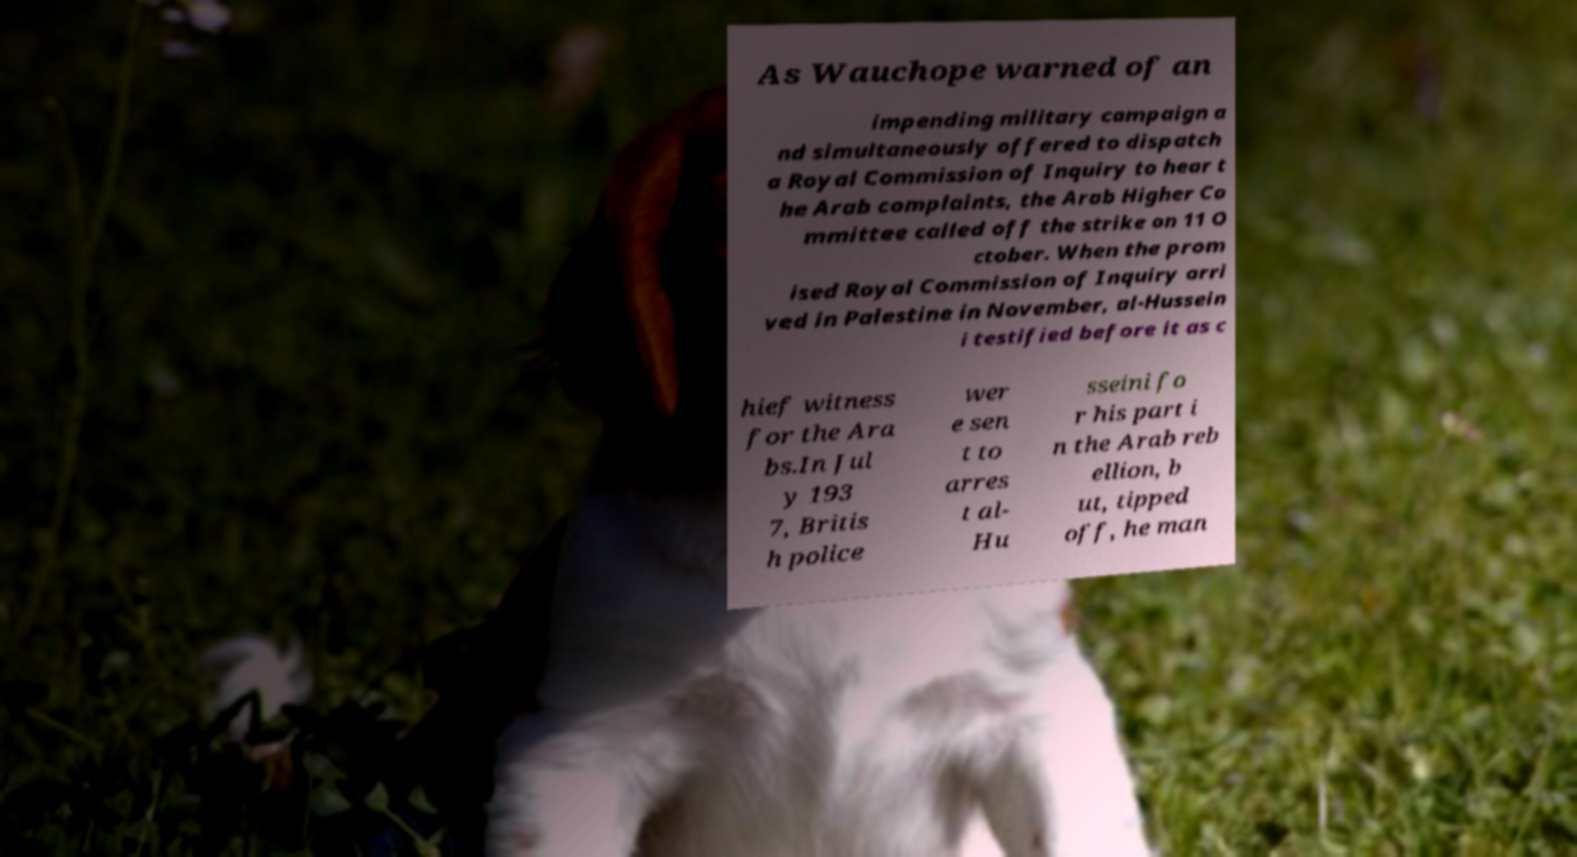Can you read and provide the text displayed in the image?This photo seems to have some interesting text. Can you extract and type it out for me? As Wauchope warned of an impending military campaign a nd simultaneously offered to dispatch a Royal Commission of Inquiry to hear t he Arab complaints, the Arab Higher Co mmittee called off the strike on 11 O ctober. When the prom ised Royal Commission of Inquiry arri ved in Palestine in November, al-Hussein i testified before it as c hief witness for the Ara bs.In Jul y 193 7, Britis h police wer e sen t to arres t al- Hu sseini fo r his part i n the Arab reb ellion, b ut, tipped off, he man 